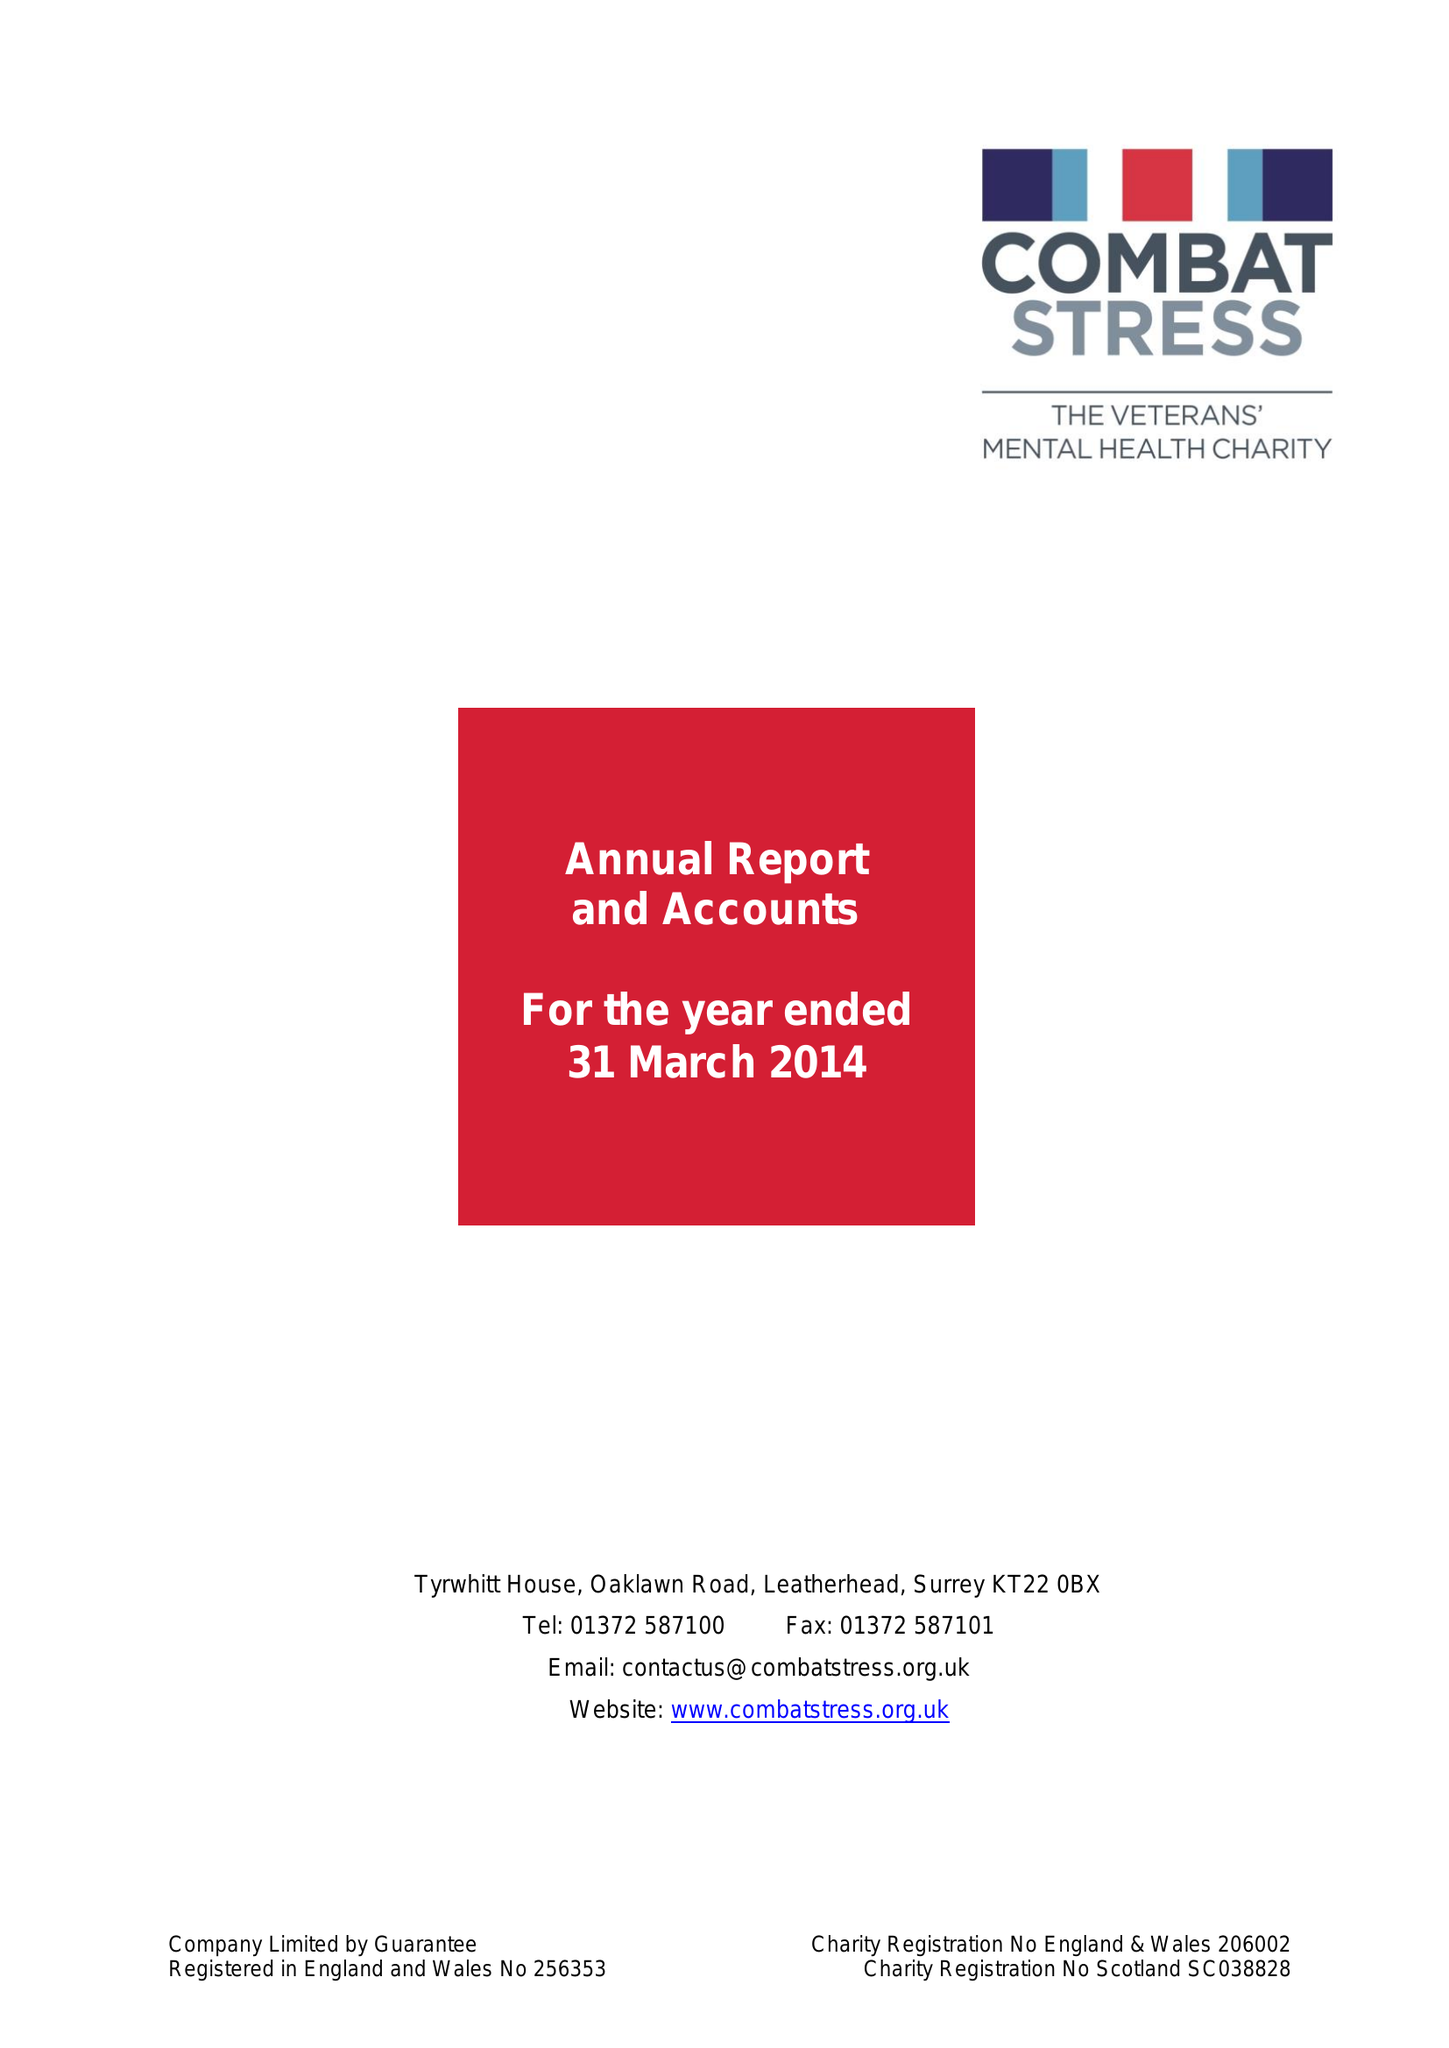What is the value for the income_annually_in_british_pounds?
Answer the question using a single word or phrase. 17385000.00 